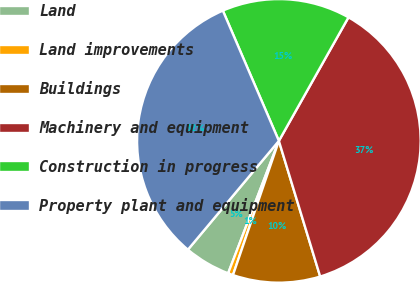Convert chart. <chart><loc_0><loc_0><loc_500><loc_500><pie_chart><fcel>Land<fcel>Land improvements<fcel>Buildings<fcel>Machinery and equipment<fcel>Construction in progress<fcel>Property plant and equipment<nl><fcel>5.26%<fcel>0.58%<fcel>9.95%<fcel>37.13%<fcel>14.63%<fcel>32.45%<nl></chart> 